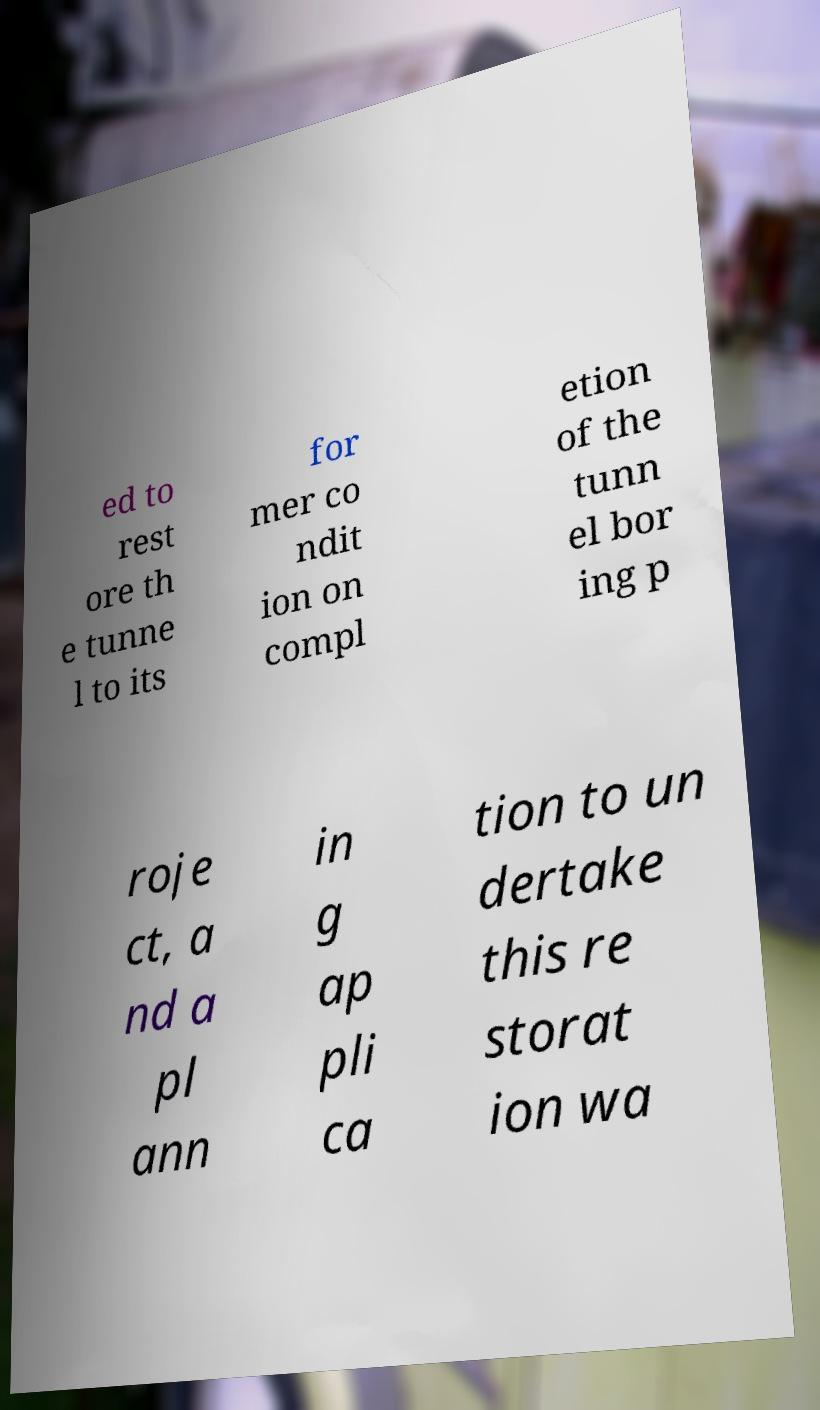Can you accurately transcribe the text from the provided image for me? ed to rest ore th e tunne l to its for mer co ndit ion on compl etion of the tunn el bor ing p roje ct, a nd a pl ann in g ap pli ca tion to un dertake this re storat ion wa 